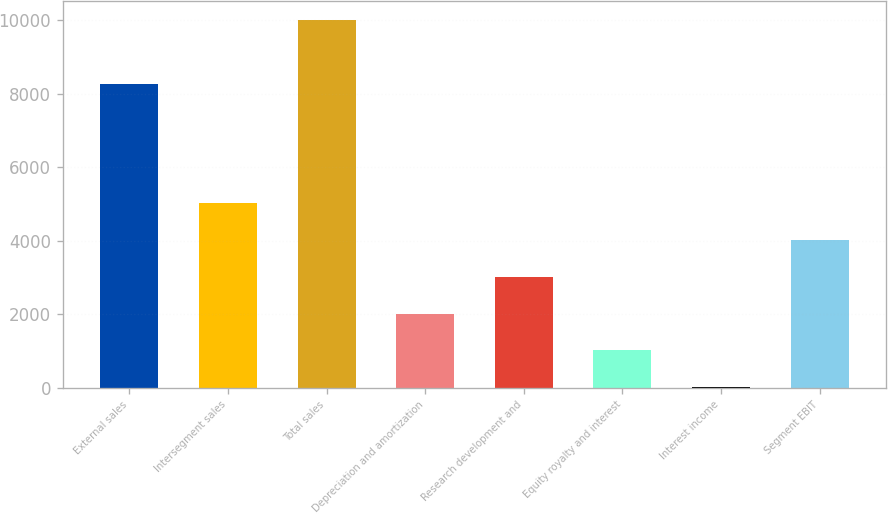Convert chart. <chart><loc_0><loc_0><loc_500><loc_500><bar_chart><fcel>External sales<fcel>Intersegment sales<fcel>Total sales<fcel>Depreciation and amortization<fcel>Research development and<fcel>Equity royalty and interest<fcel>Interest income<fcel>Segment EBIT<nl><fcel>8270<fcel>5014.5<fcel>10013<fcel>2015.4<fcel>3015.1<fcel>1015.7<fcel>16<fcel>4014.8<nl></chart> 